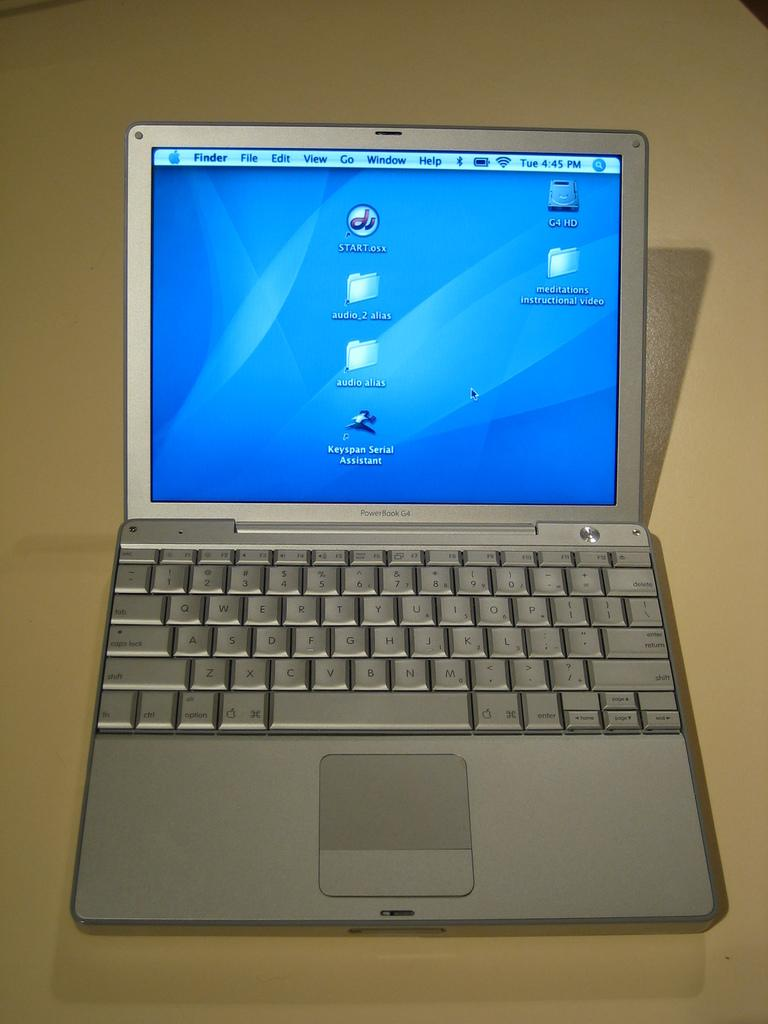<image>
Provide a brief description of the given image. an old Mac powerbook G4 laptop with a clean desktop. 